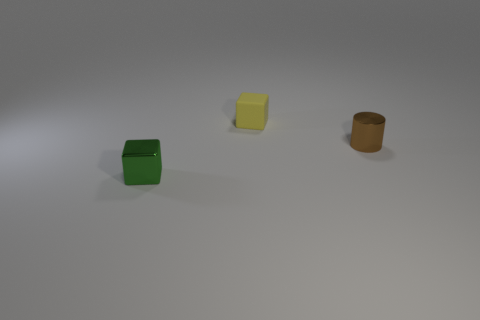Is there another thing that has the same shape as the brown metal thing?
Offer a very short reply. No. Is the shape of the tiny metallic thing in front of the brown thing the same as the thing behind the tiny brown object?
Your answer should be compact. Yes. There is a yellow object that is the same size as the green object; what is it made of?
Your answer should be compact. Rubber. How many other objects are the same material as the brown cylinder?
Your answer should be very brief. 1. There is a shiny object behind the thing on the left side of the matte thing; what is its shape?
Provide a short and direct response. Cylinder. How many objects are either brown metallic objects or tiny cubes that are behind the small green shiny cube?
Keep it short and to the point. 2. How many other objects are the same color as the cylinder?
Ensure brevity in your answer.  0. How many brown things are either small shiny cylinders or rubber blocks?
Your answer should be very brief. 1. Are there any small yellow things that are in front of the tiny object that is in front of the metallic object that is on the right side of the rubber cube?
Your response must be concise. No. Is there any other thing that has the same size as the yellow thing?
Offer a terse response. Yes. 